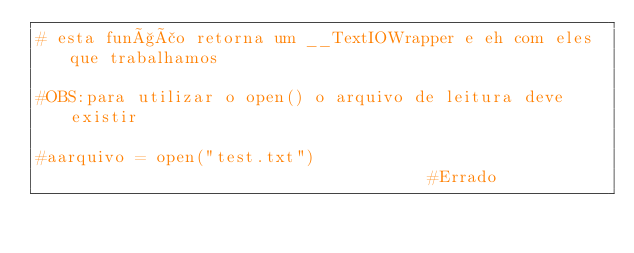Convert code to text. <code><loc_0><loc_0><loc_500><loc_500><_Python_># esta função retorna um __TextIOWrapper e eh com eles que trabalhamos

#OBS:para utilizar o open() o arquivo de leitura deve existir

#aarquivo = open("test.txt")                                     #Errado</code> 